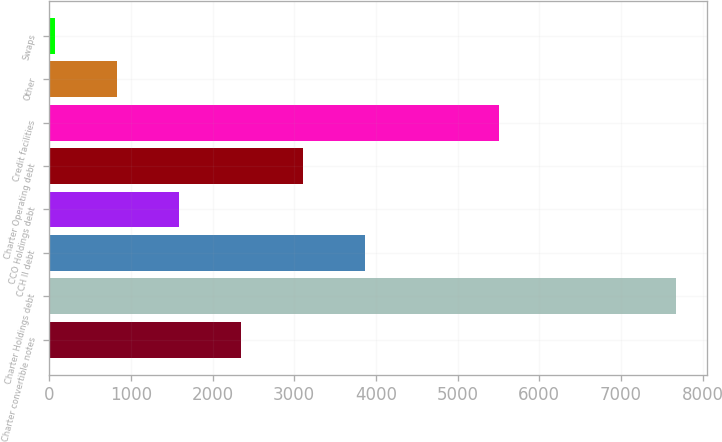Convert chart to OTSL. <chart><loc_0><loc_0><loc_500><loc_500><bar_chart><fcel>Charter convertible notes<fcel>Charter Holdings debt<fcel>CCH II debt<fcel>CCO Holdings debt<fcel>Charter Operating debt<fcel>Credit facilities<fcel>Other<fcel>Swaps<nl><fcel>2349<fcel>7669<fcel>3869<fcel>1589<fcel>3109<fcel>5502<fcel>829<fcel>69<nl></chart> 